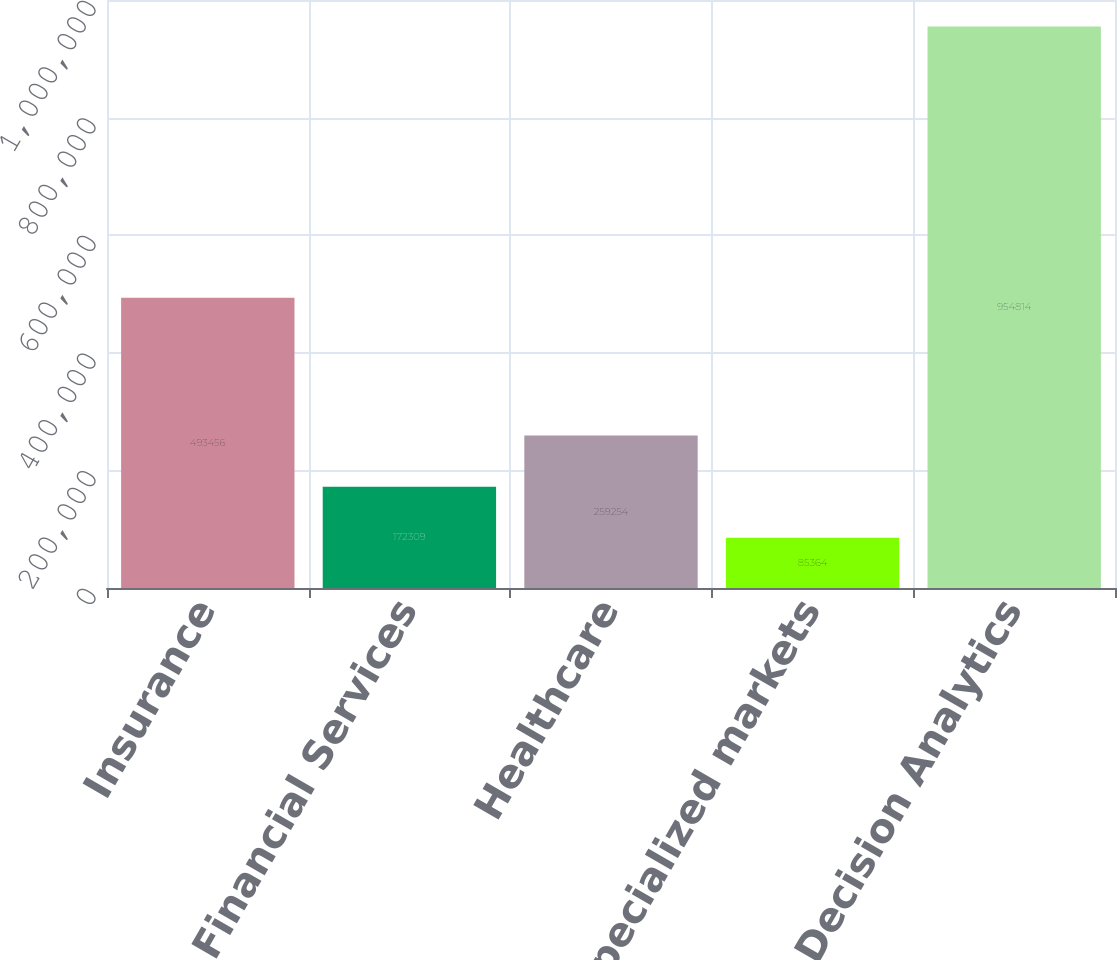<chart> <loc_0><loc_0><loc_500><loc_500><bar_chart><fcel>Insurance<fcel>Financial Services<fcel>Healthcare<fcel>Specialized markets<fcel>Total Decision Analytics<nl><fcel>493456<fcel>172309<fcel>259254<fcel>85364<fcel>954814<nl></chart> 